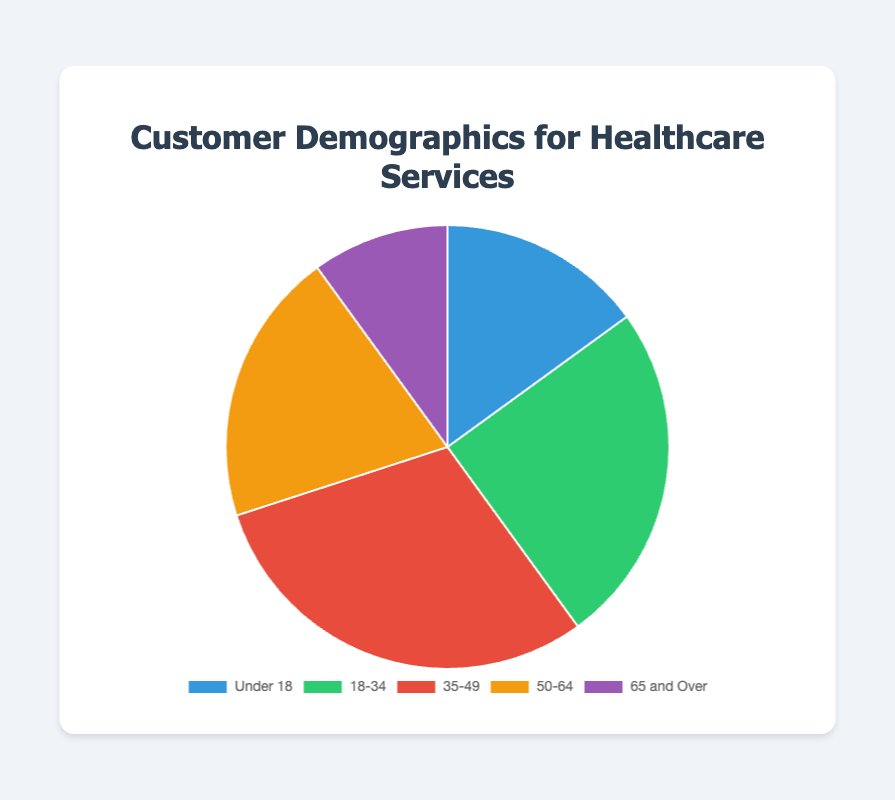What is the percentage of customers who are aged between 18-34? The pie chart shows that the percentage of customers aged between 18-34 is 25%. By looking at the segment labeled '18-34', we can directly read off this percentage.
Answer: 25% Which age group has the highest volume of customers? By examining the pie chart segments, the '35-49' age group is visibly the largest, indicating the highest volume of customers at 30%.
Answer: 35-49 How does the percentage of customers aged 50-64 compare to those aged under 18? The two relevant segments show that the percentage for 50-64 is 20%, while for Under 18, it's 15%. Thus, the percentage for 50-64 is higher.
Answer: 50-64 has a higher percentage What is the combined percentage for customers under 18 and 65 and over? Adding the percentages for the 'Under 18' (15%) and '65 and Over' (10%) segments gives us 15% + 10% = 25%.
Answer: 25% Which age group is represented by the green segment in the pie chart? The green color corresponds to the second segment in the data, which is the '18-34' age group.
Answer: 18-34 What is the difference in the percentage of customers between the age groups '35-49' and '65 and Over'? Subtracting the percentages, 30% (35-49) - 10% (65 and Over) gives 20%.
Answer: 20% If you combine the 18-34 and 50-64 age groups, what percentage of the total does this group represent? Adding the percentages for the '18-34' (25%) and '50-64' (20%) segments, we get 25% + 20% = 45%.
Answer: 45% Which age group has the smallest representation in the pie chart? The '65 and Over' segment shows the smallest percentage at 10%.
Answer: 65 and Over What is the average percentage of the age groups 'Under 18', '18-34' and '50-64'? Summing the percentages 15%, 25%, and 20% results in 60%. Dividing by 3 gives 60% / 3 = 20%.
Answer: 20% Is the percentage of customers aged 35-49 higher or lower than the sum of percentages for 'Under 18' and '65 and Over'? The '35-49' age group is 30%, while the sum of 'Under 18' (15%) and '65 and Over' (10%) is 25%. 30% is higher than 25%.
Answer: Higher 